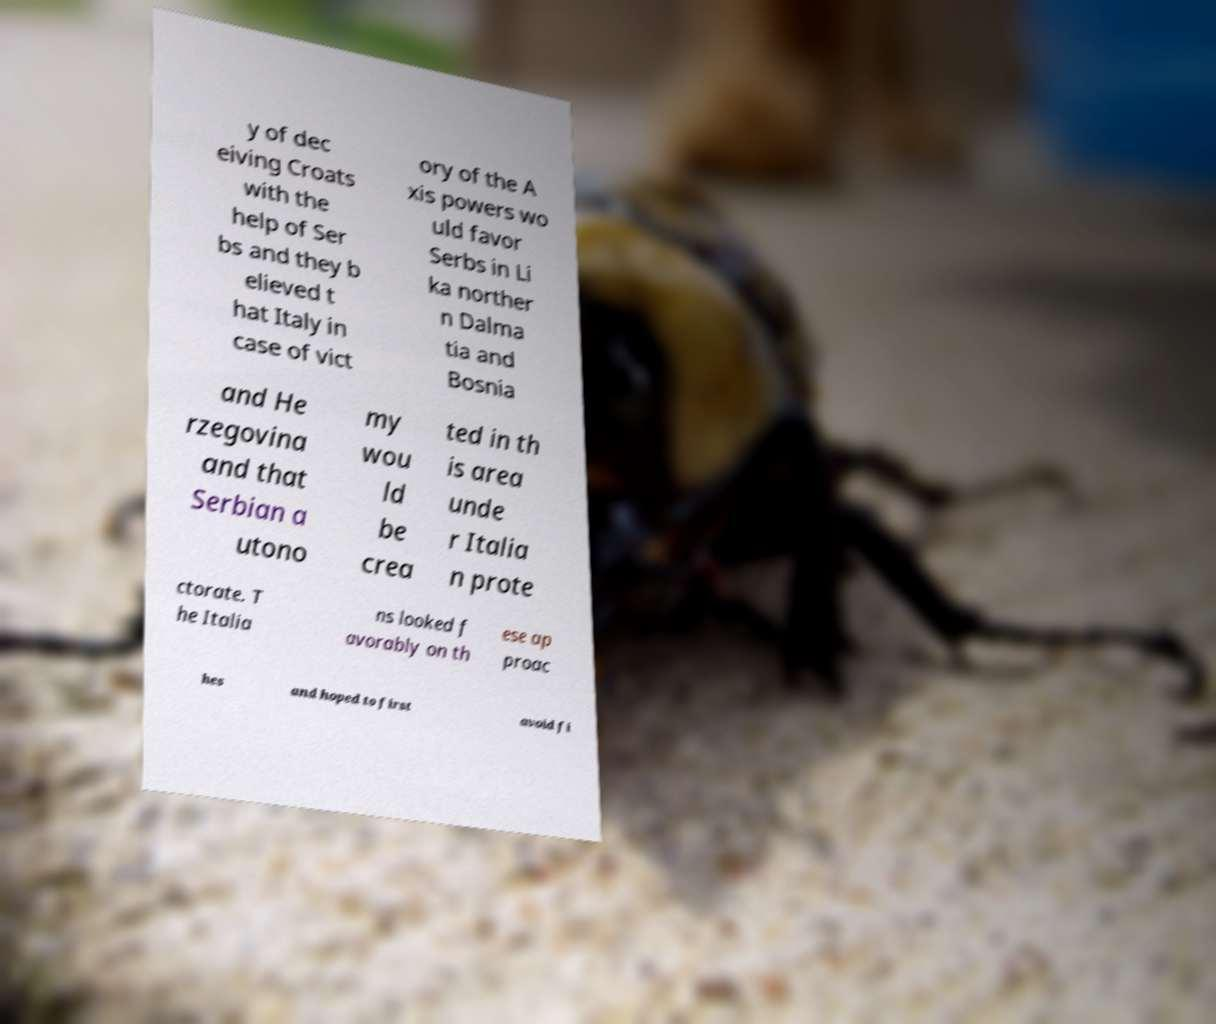Please identify and transcribe the text found in this image. y of dec eiving Croats with the help of Ser bs and they b elieved t hat Italy in case of vict ory of the A xis powers wo uld favor Serbs in Li ka norther n Dalma tia and Bosnia and He rzegovina and that Serbian a utono my wou ld be crea ted in th is area unde r Italia n prote ctorate. T he Italia ns looked f avorably on th ese ap proac hes and hoped to first avoid fi 